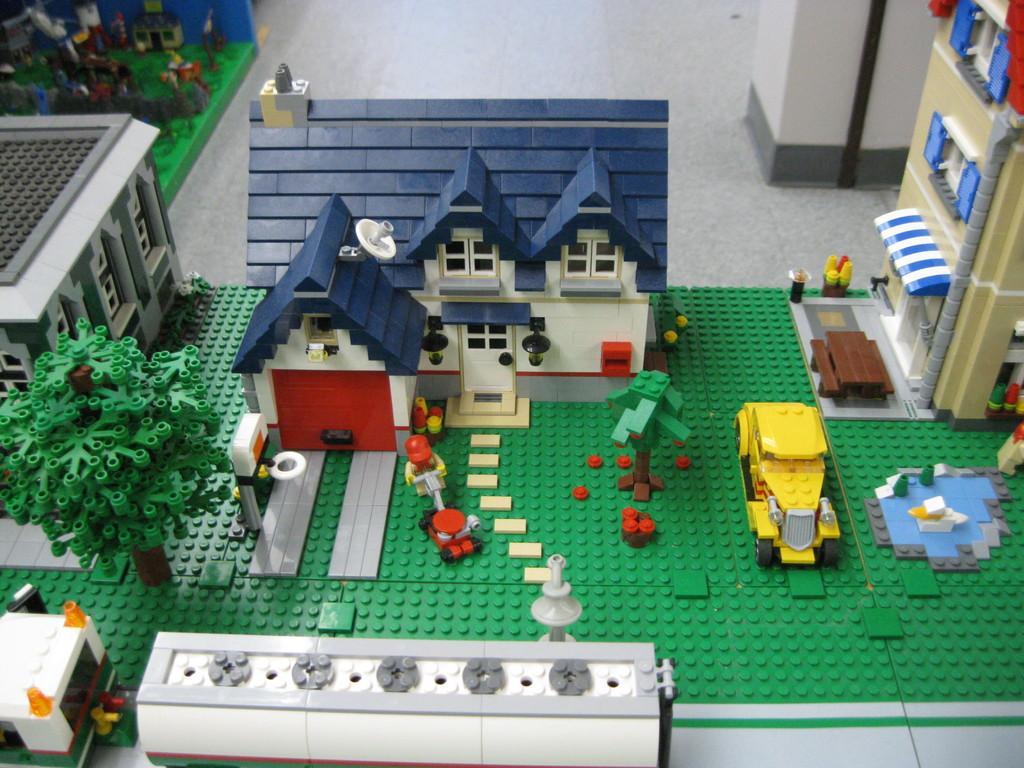Can you describe this image briefly? In this picture we can see buildings with windows, trees, vehicles and some objects and these all are made of building blocks. 